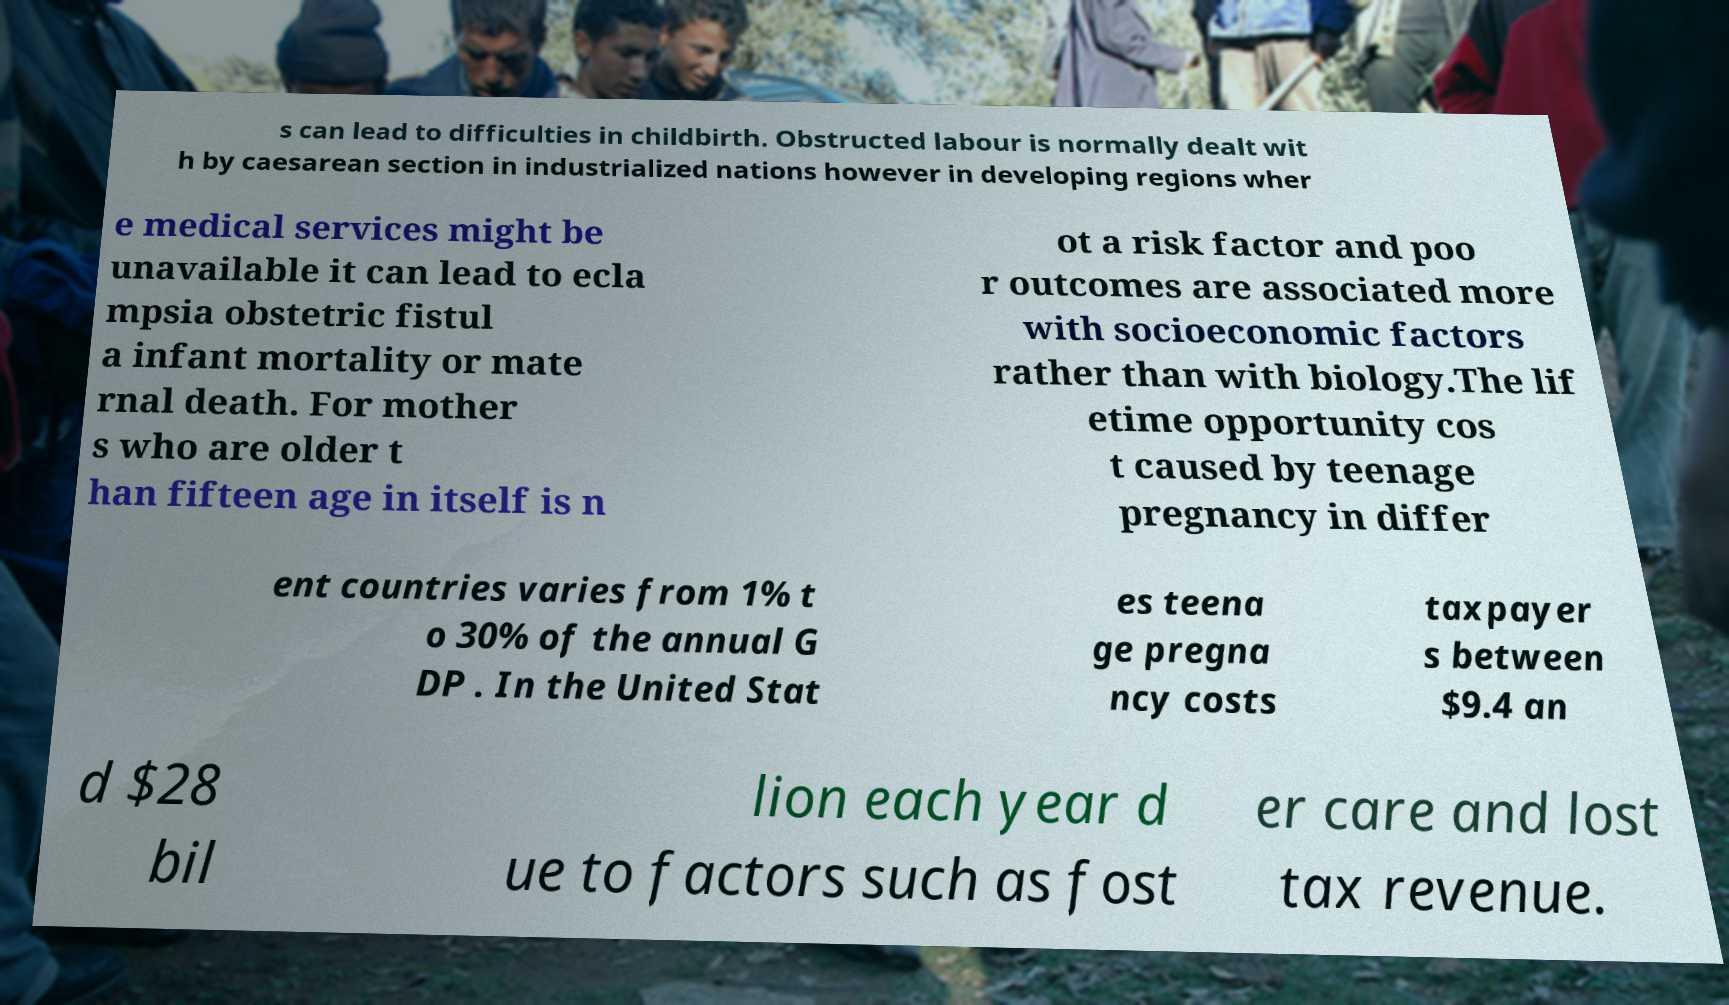I need the written content from this picture converted into text. Can you do that? s can lead to difficulties in childbirth. Obstructed labour is normally dealt wit h by caesarean section in industrialized nations however in developing regions wher e medical services might be unavailable it can lead to ecla mpsia obstetric fistul a infant mortality or mate rnal death. For mother s who are older t han fifteen age in itself is n ot a risk factor and poo r outcomes are associated more with socioeconomic factors rather than with biology.The lif etime opportunity cos t caused by teenage pregnancy in differ ent countries varies from 1% t o 30% of the annual G DP . In the United Stat es teena ge pregna ncy costs taxpayer s between $9.4 an d $28 bil lion each year d ue to factors such as fost er care and lost tax revenue. 